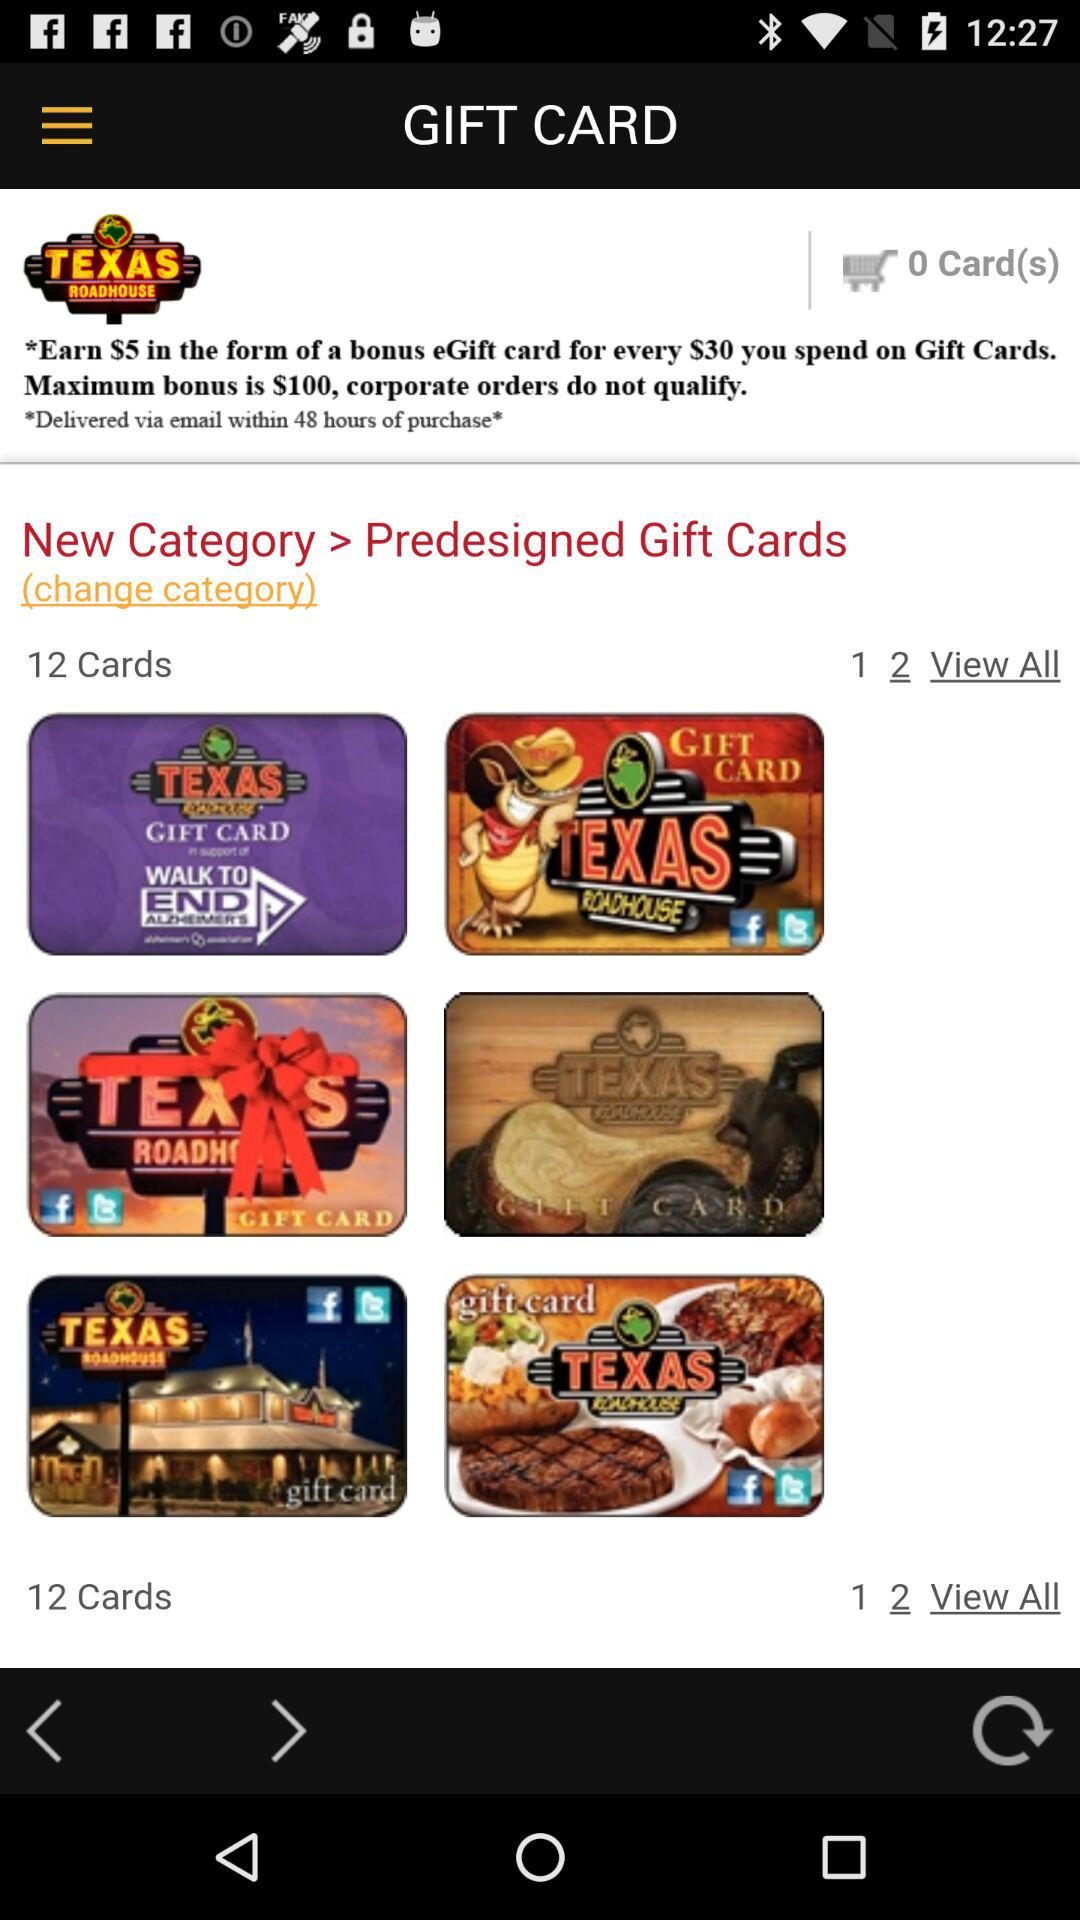How many cards are available in "Predesigned Gift Cards"? There are 12 cards available. 